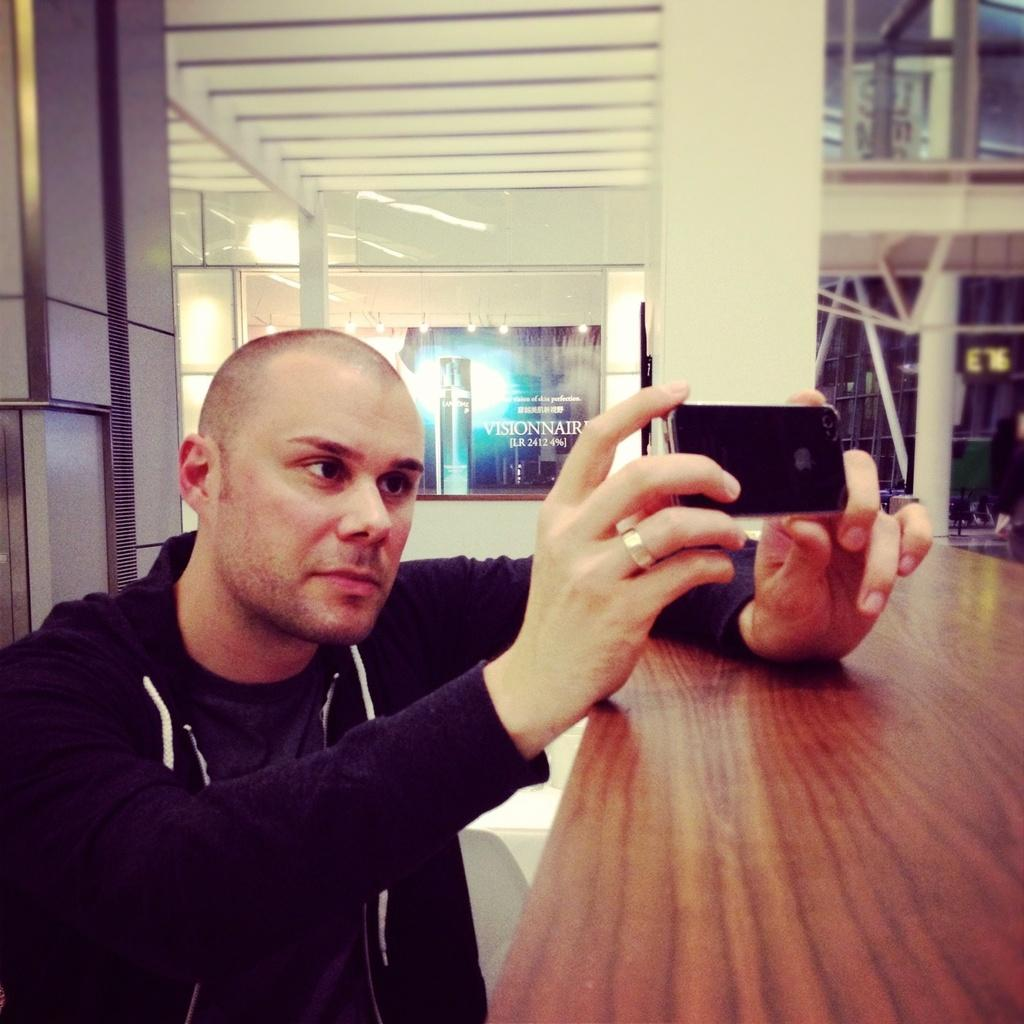What is the main subject of the image? There is a man in the image. What is the man holding in his hands? The man is holding a mobile in his hands. What can be seen in the background of the image? There are pillars, lights, glass, and a banner in the background of the image. What type of powder is being advertised on the banner in the image? There is no powder being advertised on the banner in the image; it is not visible or mentioned in the provided facts. 